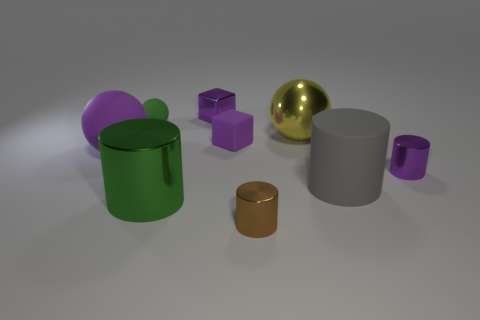There is a metallic block; is its color the same as the metal cylinder that is behind the gray rubber cylinder?
Your answer should be very brief. Yes. Are there an equal number of tiny matte objects in front of the big gray matte object and matte objects that are on the right side of the yellow ball?
Give a very brief answer. No. What material is the big object that is to the left of the large green metal object?
Your answer should be compact. Rubber. How many things are cylinders in front of the big gray rubber thing or large shiny spheres?
Make the answer very short. 3. What number of other things are there of the same shape as the brown metallic thing?
Provide a short and direct response. 3. Do the matte object that is behind the rubber cube and the large purple thing have the same shape?
Ensure brevity in your answer.  Yes. There is a purple rubber cube; are there any large shiny balls right of it?
Ensure brevity in your answer.  Yes. How many tiny objects are either brown metal cubes or brown metal cylinders?
Keep it short and to the point. 1. Is the material of the big green thing the same as the purple sphere?
Provide a short and direct response. No. There is a metal cylinder that is the same color as the matte cube; what size is it?
Provide a short and direct response. Small. 